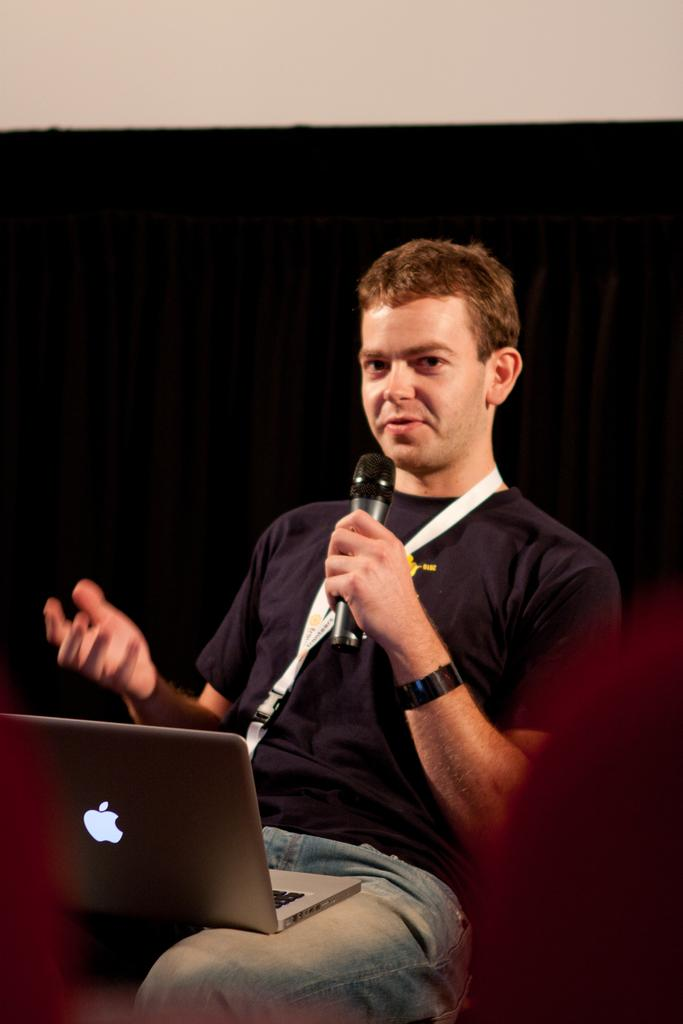Who is the main subject in the image? There is a man in the middle of the image. What is the man wearing on his upper body? The man is wearing a blue t-shirt. What type of pants is the man wearing? The man is wearing trousers. What accessory is the man wearing on his wrist? The man is wearing a watch. What is attached to the man's clothing? The man has a tag. What object is the man holding or using? The man has a laptop on his lap. What action is the man performing in the image? The man appears to be speaking. What type of store can be seen in the background of the image? There is no store visible in the image; it only features a man with a laptop on his lap. What class is the man teaching in the image? There is no indication that the man is teaching a class in the image. 